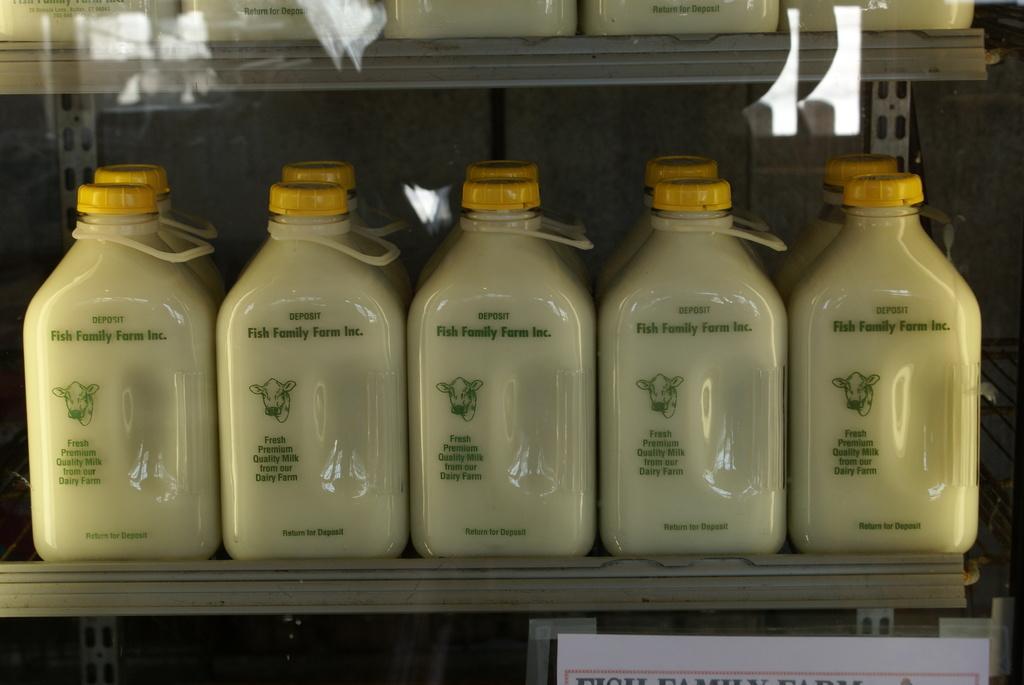Please provide a concise description of this image. In this picture we can bottles. 